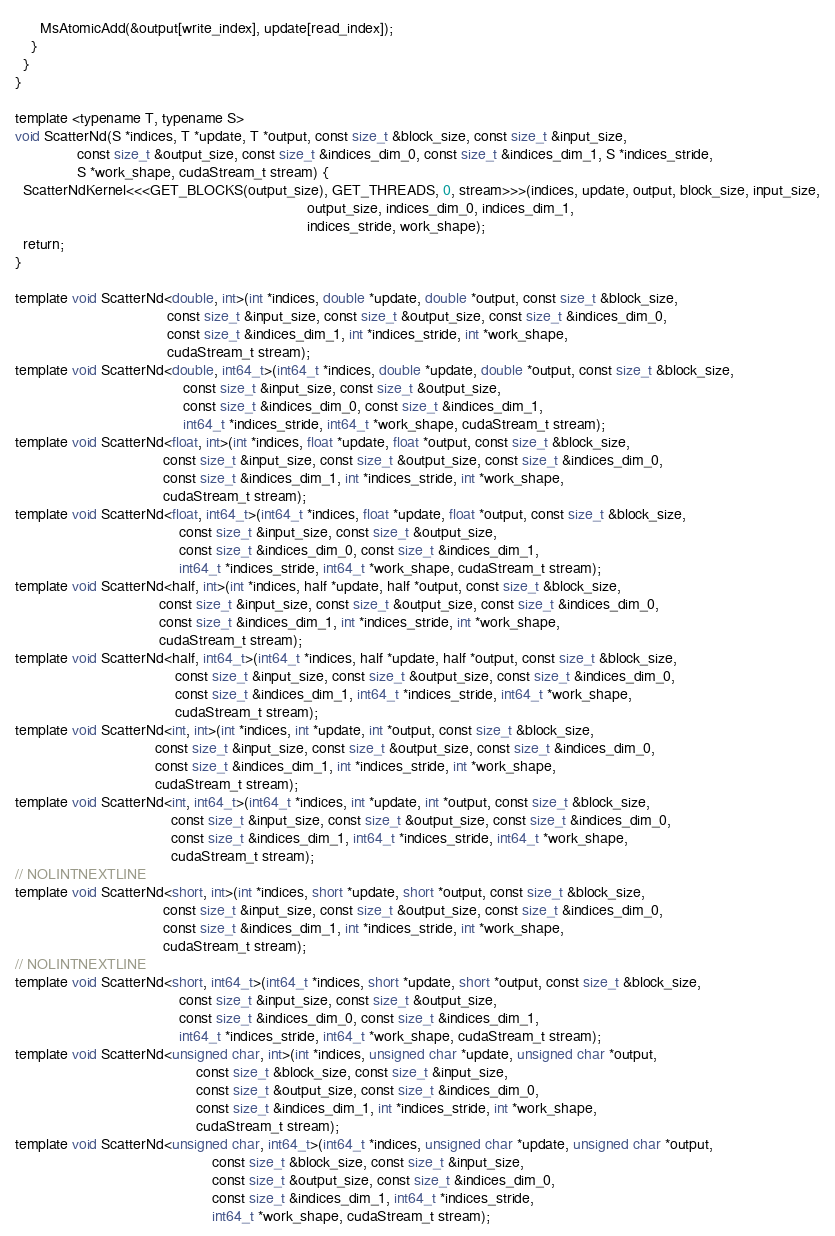Convert code to text. <code><loc_0><loc_0><loc_500><loc_500><_Cuda_>      MsAtomicAdd(&output[write_index], update[read_index]);
    }
  }
}

template <typename T, typename S>
void ScatterNd(S *indices, T *update, T *output, const size_t &block_size, const size_t &input_size,
               const size_t &output_size, const size_t &indices_dim_0, const size_t &indices_dim_1, S *indices_stride,
               S *work_shape, cudaStream_t stream) {
  ScatterNdKernel<<<GET_BLOCKS(output_size), GET_THREADS, 0, stream>>>(indices, update, output, block_size, input_size,
                                                                       output_size, indices_dim_0, indices_dim_1,
                                                                       indices_stride, work_shape);
  return;
}

template void ScatterNd<double, int>(int *indices, double *update, double *output, const size_t &block_size,
                                     const size_t &input_size, const size_t &output_size, const size_t &indices_dim_0,
                                     const size_t &indices_dim_1, int *indices_stride, int *work_shape,
                                     cudaStream_t stream);
template void ScatterNd<double, int64_t>(int64_t *indices, double *update, double *output, const size_t &block_size,
                                         const size_t &input_size, const size_t &output_size,
                                         const size_t &indices_dim_0, const size_t &indices_dim_1,
                                         int64_t *indices_stride, int64_t *work_shape, cudaStream_t stream);
template void ScatterNd<float, int>(int *indices, float *update, float *output, const size_t &block_size,
                                    const size_t &input_size, const size_t &output_size, const size_t &indices_dim_0,
                                    const size_t &indices_dim_1, int *indices_stride, int *work_shape,
                                    cudaStream_t stream);
template void ScatterNd<float, int64_t>(int64_t *indices, float *update, float *output, const size_t &block_size,
                                        const size_t &input_size, const size_t &output_size,
                                        const size_t &indices_dim_0, const size_t &indices_dim_1,
                                        int64_t *indices_stride, int64_t *work_shape, cudaStream_t stream);
template void ScatterNd<half, int>(int *indices, half *update, half *output, const size_t &block_size,
                                   const size_t &input_size, const size_t &output_size, const size_t &indices_dim_0,
                                   const size_t &indices_dim_1, int *indices_stride, int *work_shape,
                                   cudaStream_t stream);
template void ScatterNd<half, int64_t>(int64_t *indices, half *update, half *output, const size_t &block_size,
                                       const size_t &input_size, const size_t &output_size, const size_t &indices_dim_0,
                                       const size_t &indices_dim_1, int64_t *indices_stride, int64_t *work_shape,
                                       cudaStream_t stream);
template void ScatterNd<int, int>(int *indices, int *update, int *output, const size_t &block_size,
                                  const size_t &input_size, const size_t &output_size, const size_t &indices_dim_0,
                                  const size_t &indices_dim_1, int *indices_stride, int *work_shape,
                                  cudaStream_t stream);
template void ScatterNd<int, int64_t>(int64_t *indices, int *update, int *output, const size_t &block_size,
                                      const size_t &input_size, const size_t &output_size, const size_t &indices_dim_0,
                                      const size_t &indices_dim_1, int64_t *indices_stride, int64_t *work_shape,
                                      cudaStream_t stream);
// NOLINTNEXTLINE
template void ScatterNd<short, int>(int *indices, short *update, short *output, const size_t &block_size,
                                    const size_t &input_size, const size_t &output_size, const size_t &indices_dim_0,
                                    const size_t &indices_dim_1, int *indices_stride, int *work_shape,
                                    cudaStream_t stream);
// NOLINTNEXTLINE
template void ScatterNd<short, int64_t>(int64_t *indices, short *update, short *output, const size_t &block_size,
                                        const size_t &input_size, const size_t &output_size,
                                        const size_t &indices_dim_0, const size_t &indices_dim_1,
                                        int64_t *indices_stride, int64_t *work_shape, cudaStream_t stream);
template void ScatterNd<unsigned char, int>(int *indices, unsigned char *update, unsigned char *output,
                                            const size_t &block_size, const size_t &input_size,
                                            const size_t &output_size, const size_t &indices_dim_0,
                                            const size_t &indices_dim_1, int *indices_stride, int *work_shape,
                                            cudaStream_t stream);
template void ScatterNd<unsigned char, int64_t>(int64_t *indices, unsigned char *update, unsigned char *output,
                                                const size_t &block_size, const size_t &input_size,
                                                const size_t &output_size, const size_t &indices_dim_0,
                                                const size_t &indices_dim_1, int64_t *indices_stride,
                                                int64_t *work_shape, cudaStream_t stream);
</code> 